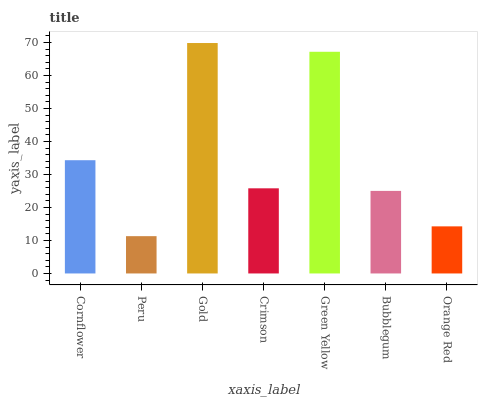Is Peru the minimum?
Answer yes or no. Yes. Is Gold the maximum?
Answer yes or no. Yes. Is Gold the minimum?
Answer yes or no. No. Is Peru the maximum?
Answer yes or no. No. Is Gold greater than Peru?
Answer yes or no. Yes. Is Peru less than Gold?
Answer yes or no. Yes. Is Peru greater than Gold?
Answer yes or no. No. Is Gold less than Peru?
Answer yes or no. No. Is Crimson the high median?
Answer yes or no. Yes. Is Crimson the low median?
Answer yes or no. Yes. Is Gold the high median?
Answer yes or no. No. Is Cornflower the low median?
Answer yes or no. No. 